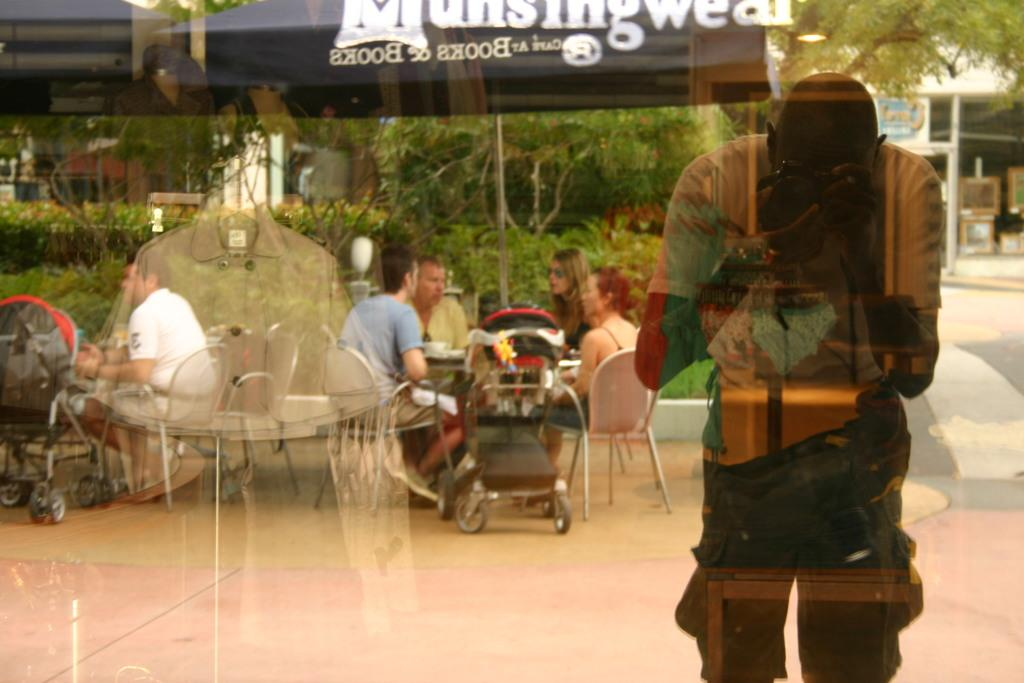What is the main activity taking place in the image? There is a group of people sitting around a table. Can you describe the man standing near a glass wall? The man is standing near a glass wall and is holding a camera. How many balls are being juggled by the servant in the image? There is no servant or balls present in the image. What type of grip does the camera have in the image? The image does not provide enough detail to determine the type of grip on the camera. 